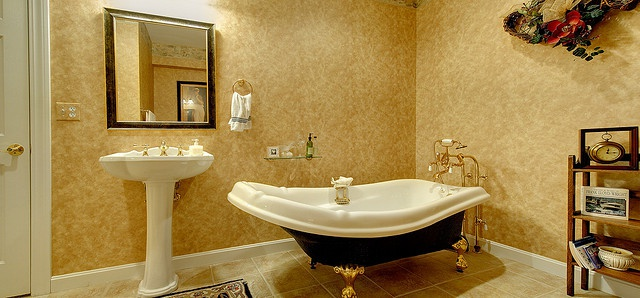Describe the objects in this image and their specific colors. I can see sink in olive, tan, and khaki tones, book in olive, tan, and black tones, vase in olive and tan tones, bowl in olive and tan tones, and book in olive, black, tan, beige, and gray tones in this image. 